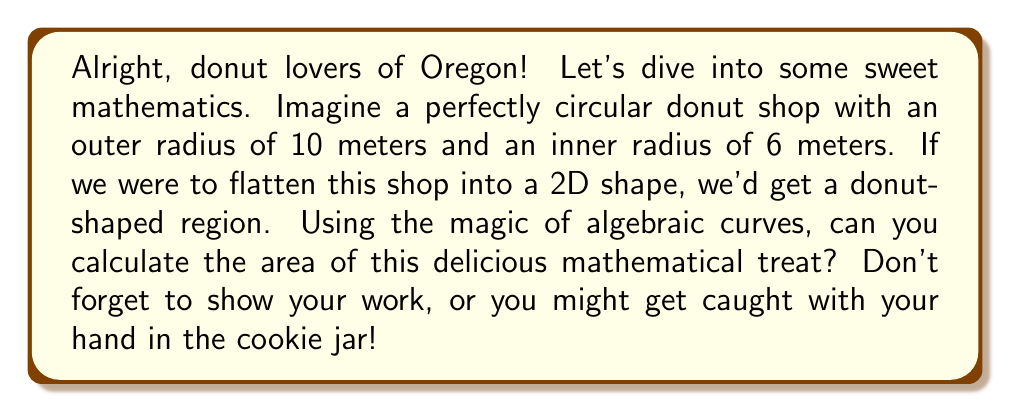What is the answer to this math problem? Let's approach this step-by-step:

1) The donut-shaped region is essentially the difference between two circles: a larger circle (the outer edge of the donut) and a smaller circle (the hole).

2) The equation of a circle in algebraic geometry is given by:

   $$ x^2 + y^2 = r^2 $$

   where $r$ is the radius of the circle.

3) For our outer circle with radius 10 meters:

   $$ x^2 + y^2 = 10^2 = 100 $$

4) For our inner circle with radius 6 meters:

   $$ x^2 + y^2 = 6^2 = 36 $$

5) The area of a circle is given by the formula $A = \pi r^2$. 

6) Area of the outer circle:

   $$ A_{outer} = \pi (10^2) = 100\pi \text{ square meters} $$

7) Area of the inner circle:

   $$ A_{inner} = \pi (6^2) = 36\pi \text{ square meters} $$

8) The area of our donut-shaped region is the difference between these two areas:

   $$ A_{donut} = A_{outer} - A_{inner} = 100\pi - 36\pi = 64\pi \text{ square meters} $$

[asy]
unitsize(10mm);
fill(circle((0,0),10), gray(0.8));
fill(circle((0,0),6), white);
draw(circle((0,0),10));
draw(circle((0,0),6));
label("10m", (5,0), E);
label("6m", (3,0), E);
[/asy]
Answer: $64\pi \text{ square meters}$ 